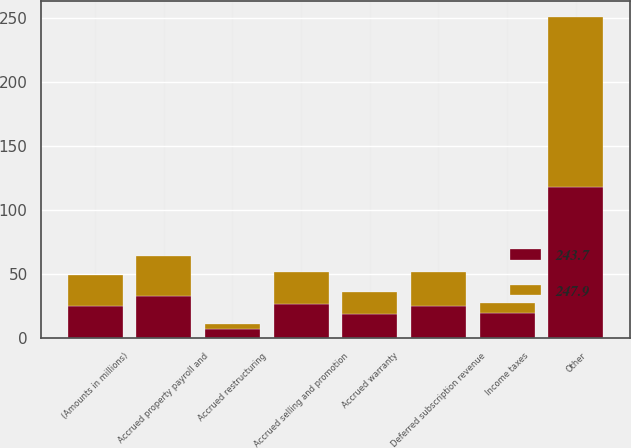Convert chart to OTSL. <chart><loc_0><loc_0><loc_500><loc_500><stacked_bar_chart><ecel><fcel>(Amounts in millions)<fcel>Income taxes<fcel>Accrued restructuring<fcel>Accrued warranty<fcel>Deferred subscription revenue<fcel>Accrued property payroll and<fcel>Accrued selling and promotion<fcel>Other<nl><fcel>247.9<fcel>24.65<fcel>7.7<fcel>4<fcel>17<fcel>26.6<fcel>31.3<fcel>24.5<fcel>132.6<nl><fcel>243.7<fcel>24.65<fcel>19.6<fcel>7.2<fcel>18.9<fcel>24.8<fcel>32.9<fcel>26.6<fcel>117.9<nl></chart> 